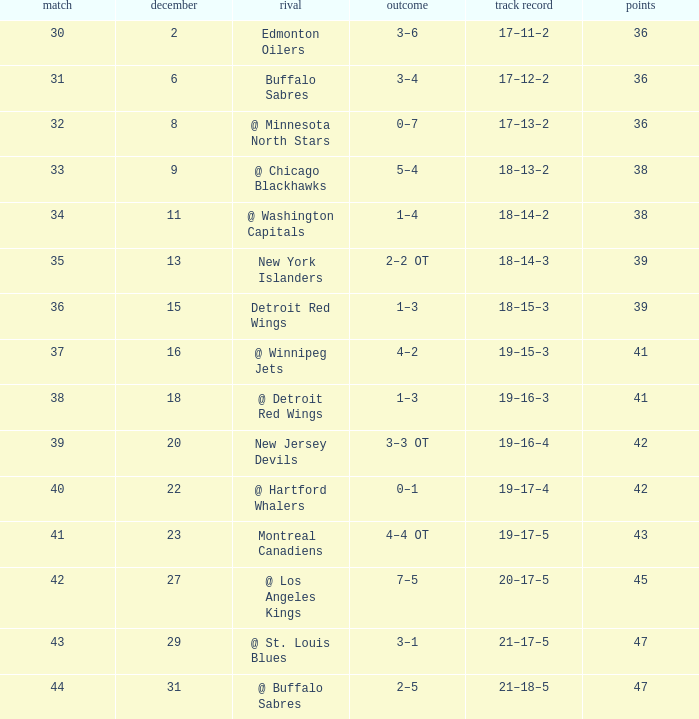After december 29 what is the score? 2–5. 